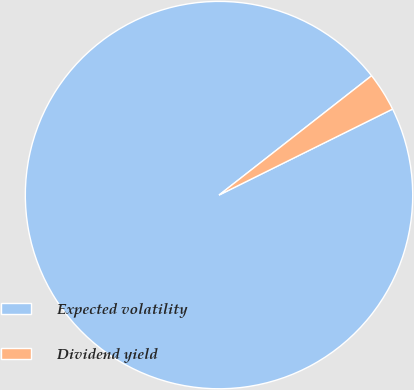Convert chart. <chart><loc_0><loc_0><loc_500><loc_500><pie_chart><fcel>Expected volatility<fcel>Dividend yield<nl><fcel>96.76%<fcel>3.24%<nl></chart> 